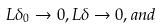<formula> <loc_0><loc_0><loc_500><loc_500>L \delta _ { 0 } \to 0 , L \delta \to 0 , a n d</formula> 